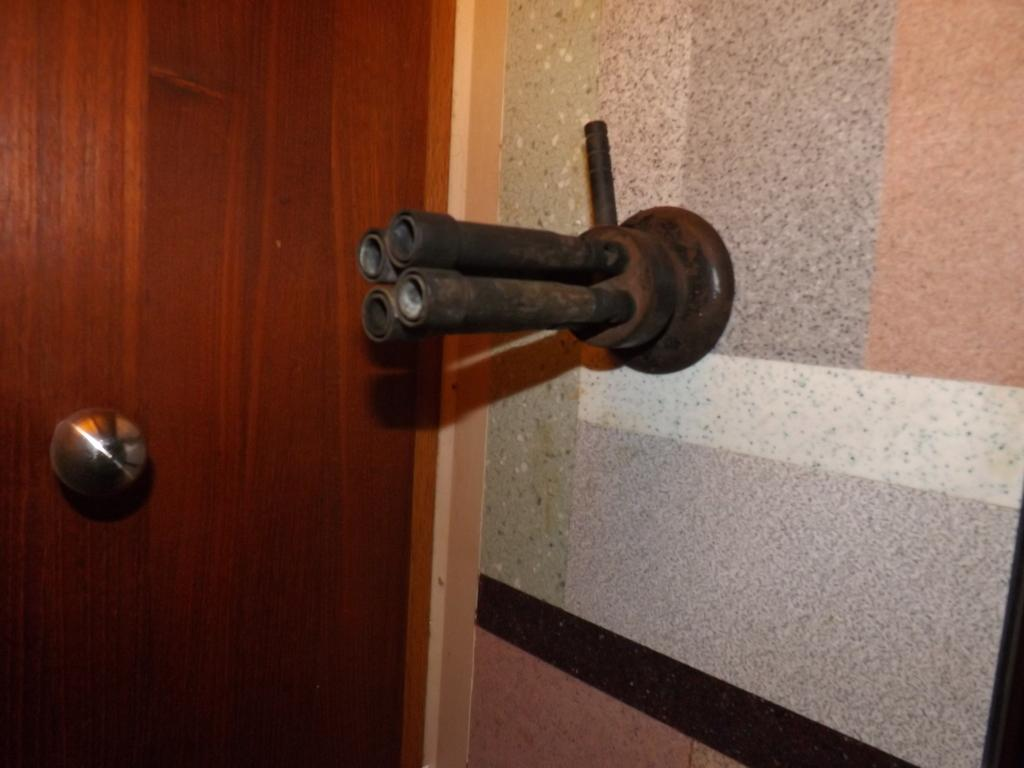What structure is located on the left side of the image? There is a door on the left side of the image. What is on the opposite side of the door in the image? There is a wall on the right side of the image. What part of the door is visible in the image? There is a door handle in the image. What type of plumbing feature can be seen in the image? There are pipes visible in the image. What type of apparatus is being used to tell jokes at the party in the image? There is no apparatus or party present in the image; it only features a door, a wall, a door handle, and pipes. 